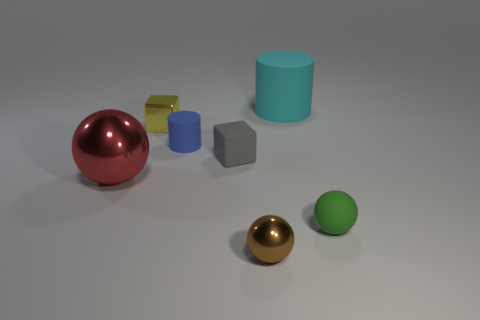Add 3 small green spheres. How many objects exist? 10 Subtract all cylinders. How many objects are left? 5 Add 1 big cyan rubber objects. How many big cyan rubber objects are left? 2 Add 7 gray metallic cubes. How many gray metallic cubes exist? 7 Subtract 1 gray cubes. How many objects are left? 6 Subtract all big cubes. Subtract all large red shiny spheres. How many objects are left? 6 